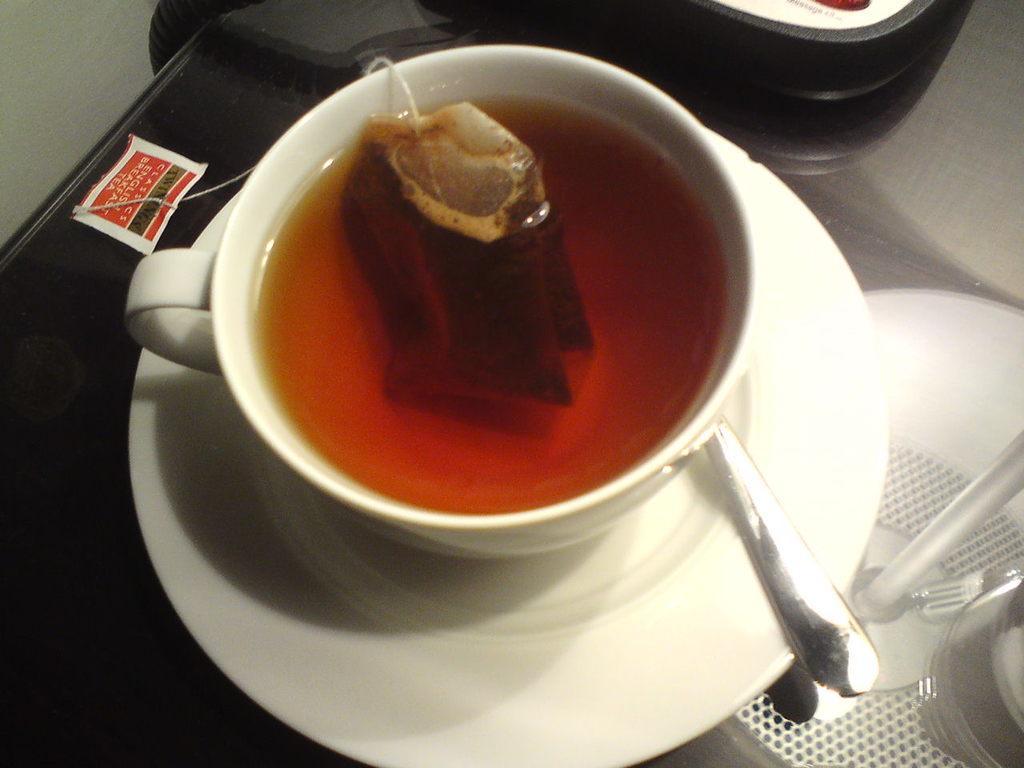Please provide a concise description of this image. There is tea and tea bag in the cup, this is saucer and spoon, this is paper. 